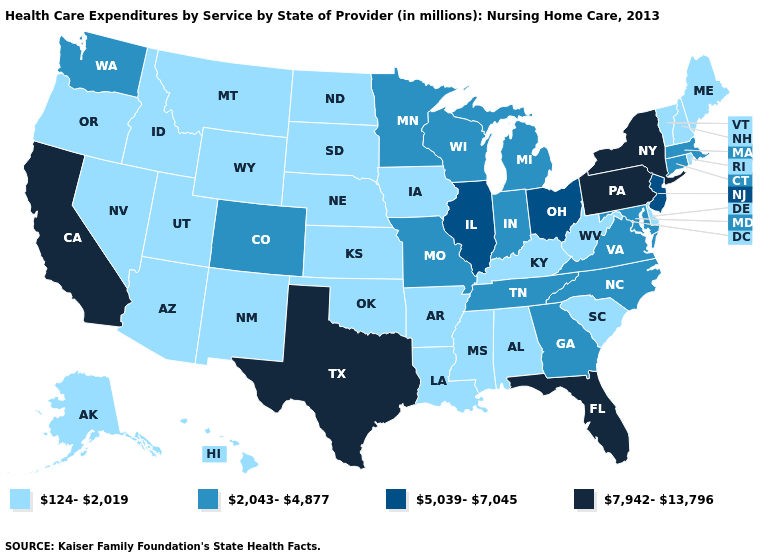Which states hav the highest value in the MidWest?
Give a very brief answer. Illinois, Ohio. Name the states that have a value in the range 2,043-4,877?
Give a very brief answer. Colorado, Connecticut, Georgia, Indiana, Maryland, Massachusetts, Michigan, Minnesota, Missouri, North Carolina, Tennessee, Virginia, Washington, Wisconsin. Among the states that border Nevada , which have the lowest value?
Short answer required. Arizona, Idaho, Oregon, Utah. How many symbols are there in the legend?
Answer briefly. 4. Which states hav the highest value in the MidWest?
Answer briefly. Illinois, Ohio. What is the highest value in states that border Texas?
Write a very short answer. 124-2,019. Name the states that have a value in the range 2,043-4,877?
Short answer required. Colorado, Connecticut, Georgia, Indiana, Maryland, Massachusetts, Michigan, Minnesota, Missouri, North Carolina, Tennessee, Virginia, Washington, Wisconsin. Name the states that have a value in the range 7,942-13,796?
Short answer required. California, Florida, New York, Pennsylvania, Texas. Does the map have missing data?
Quick response, please. No. Name the states that have a value in the range 5,039-7,045?
Write a very short answer. Illinois, New Jersey, Ohio. What is the value of Washington?
Short answer required. 2,043-4,877. What is the highest value in states that border Minnesota?
Write a very short answer. 2,043-4,877. Does Missouri have the same value as Alaska?
Short answer required. No. Name the states that have a value in the range 2,043-4,877?
Answer briefly. Colorado, Connecticut, Georgia, Indiana, Maryland, Massachusetts, Michigan, Minnesota, Missouri, North Carolina, Tennessee, Virginia, Washington, Wisconsin. Which states have the highest value in the USA?
Concise answer only. California, Florida, New York, Pennsylvania, Texas. 